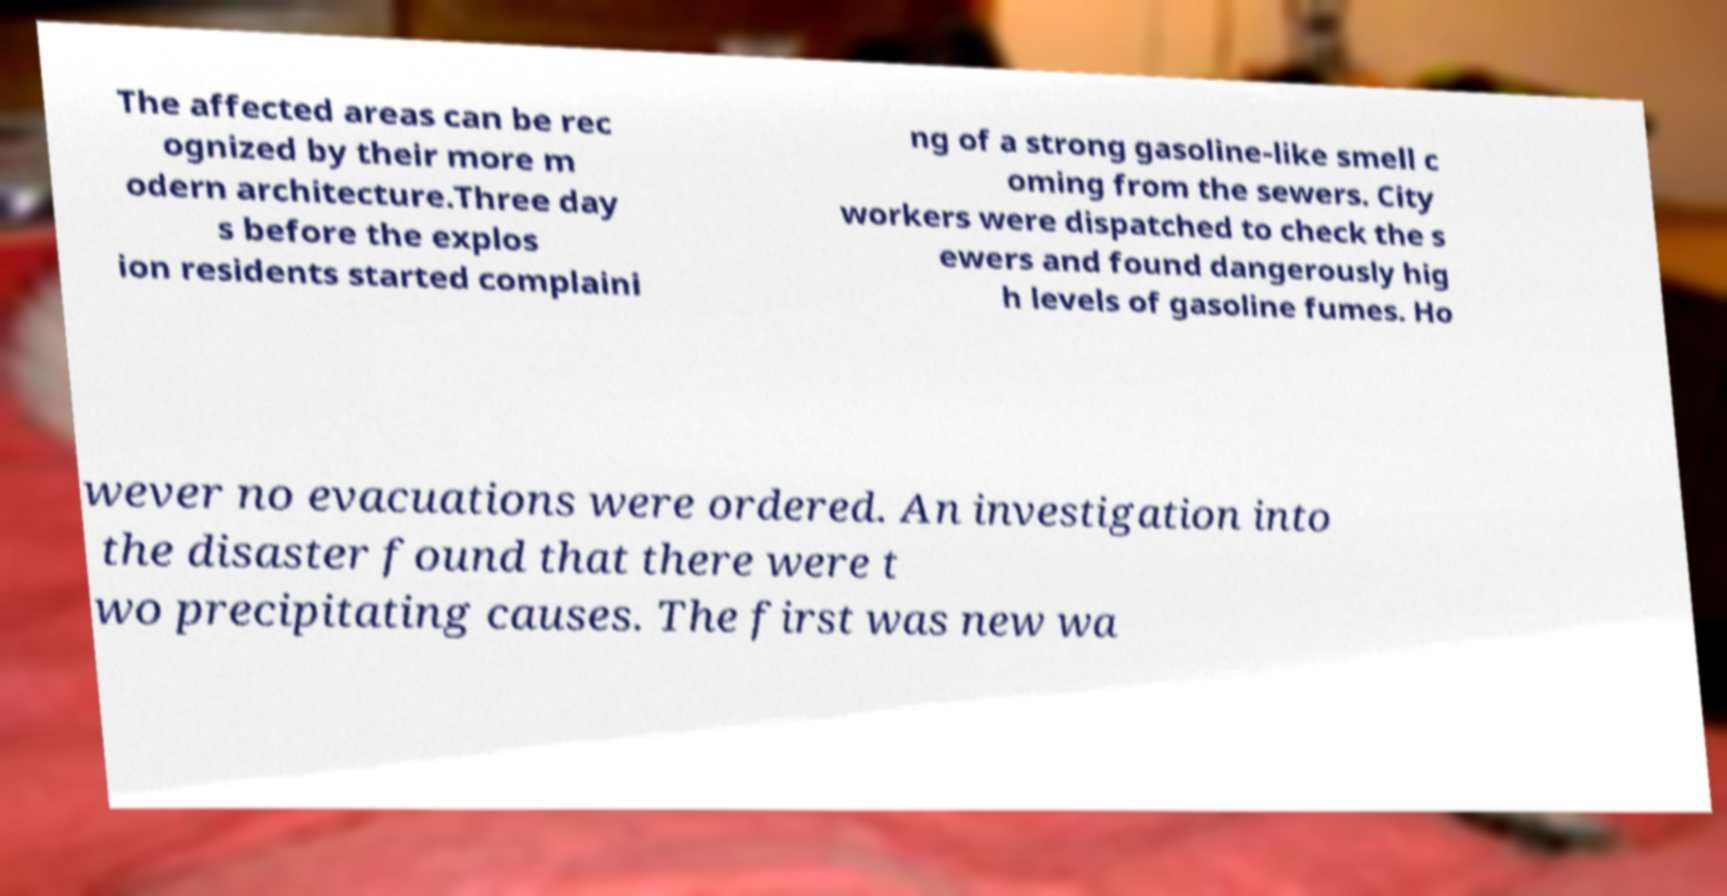Please identify and transcribe the text found in this image. The affected areas can be rec ognized by their more m odern architecture.Three day s before the explos ion residents started complaini ng of a strong gasoline-like smell c oming from the sewers. City workers were dispatched to check the s ewers and found dangerously hig h levels of gasoline fumes. Ho wever no evacuations were ordered. An investigation into the disaster found that there were t wo precipitating causes. The first was new wa 